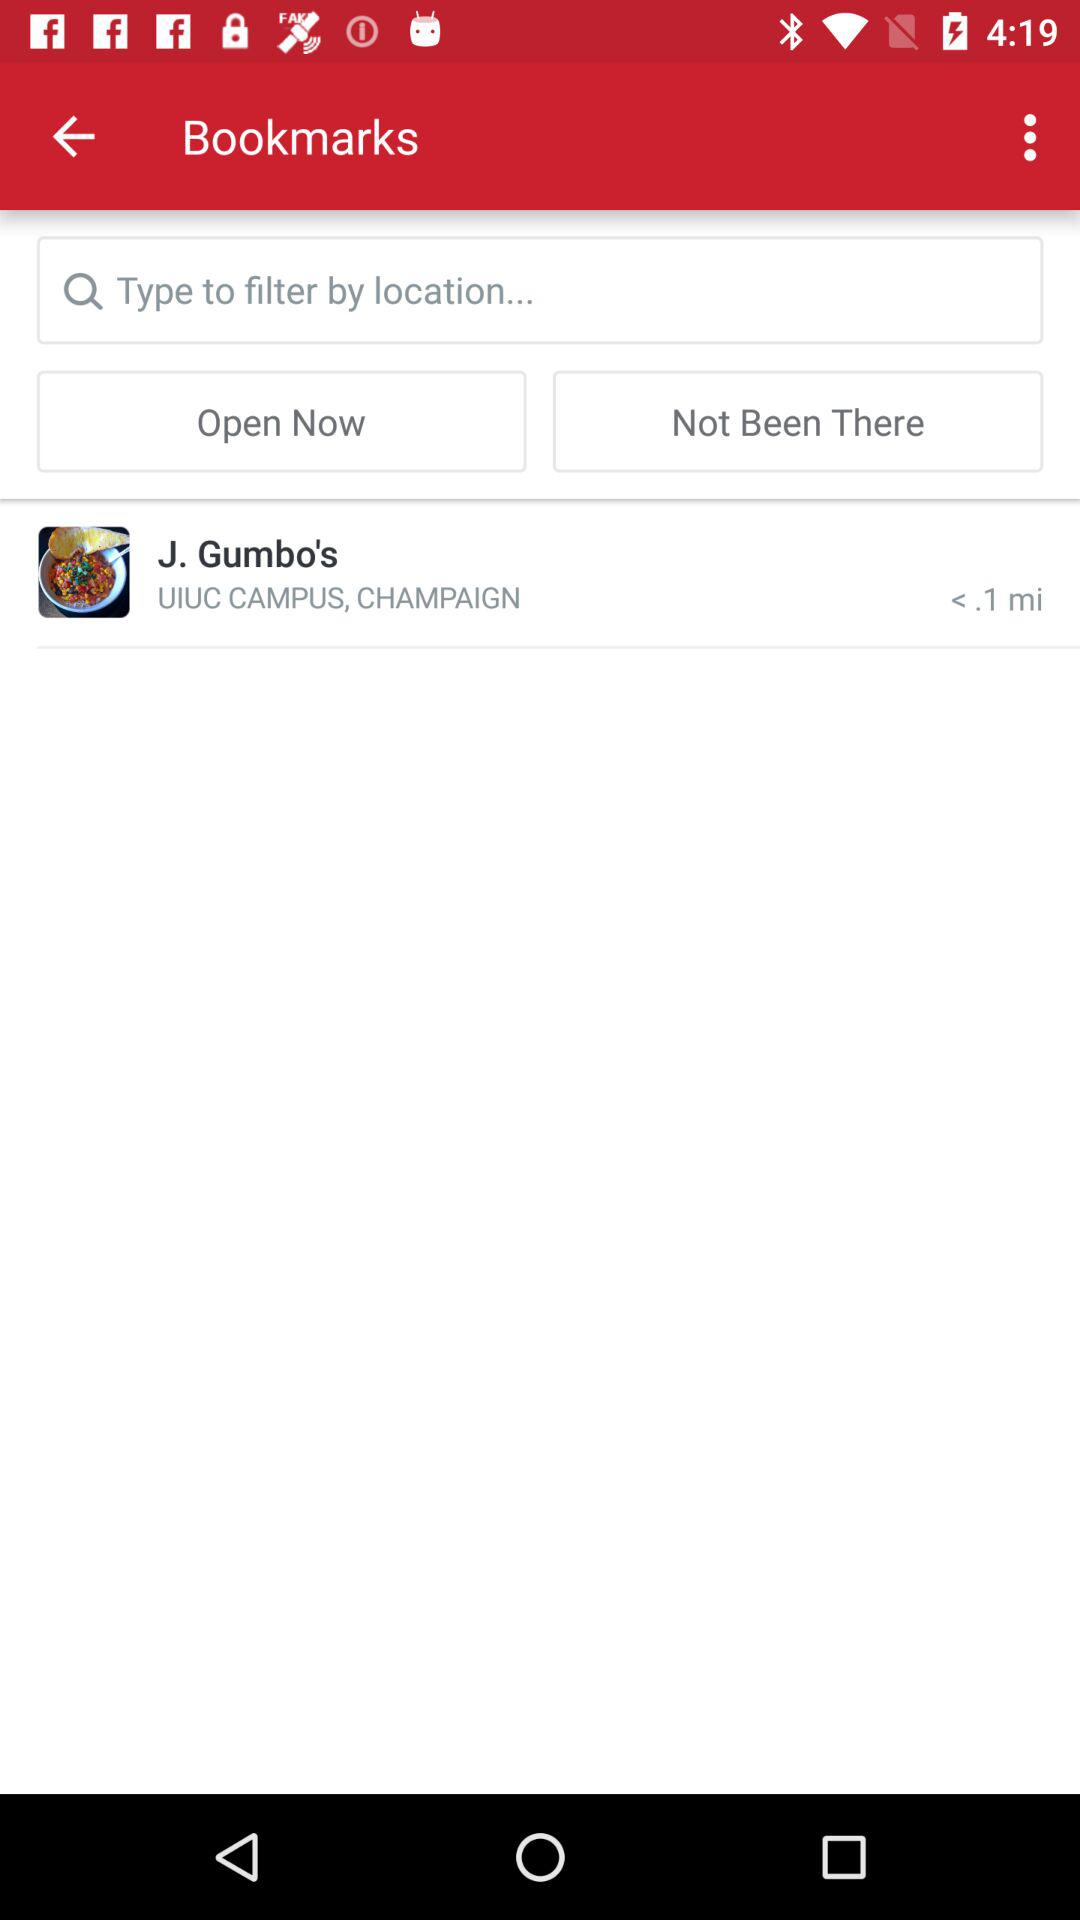How many miles away is J. Gumbo's?
Answer the question using a single word or phrase. <.1 mi 